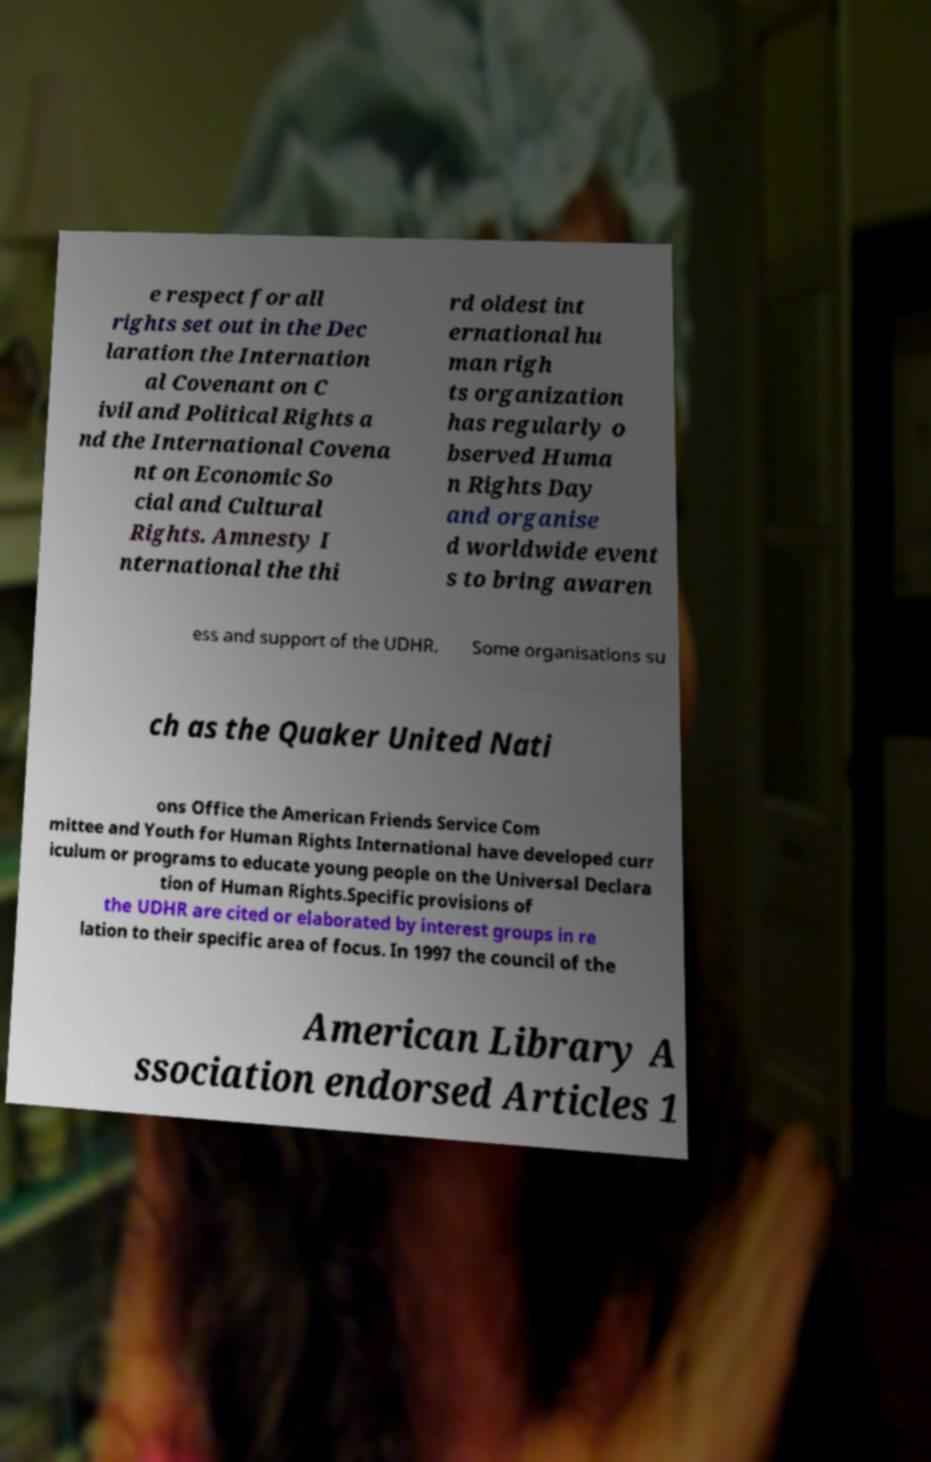For documentation purposes, I need the text within this image transcribed. Could you provide that? e respect for all rights set out in the Dec laration the Internation al Covenant on C ivil and Political Rights a nd the International Covena nt on Economic So cial and Cultural Rights. Amnesty I nternational the thi rd oldest int ernational hu man righ ts organization has regularly o bserved Huma n Rights Day and organise d worldwide event s to bring awaren ess and support of the UDHR. Some organisations su ch as the Quaker United Nati ons Office the American Friends Service Com mittee and Youth for Human Rights International have developed curr iculum or programs to educate young people on the Universal Declara tion of Human Rights.Specific provisions of the UDHR are cited or elaborated by interest groups in re lation to their specific area of focus. In 1997 the council of the American Library A ssociation endorsed Articles 1 